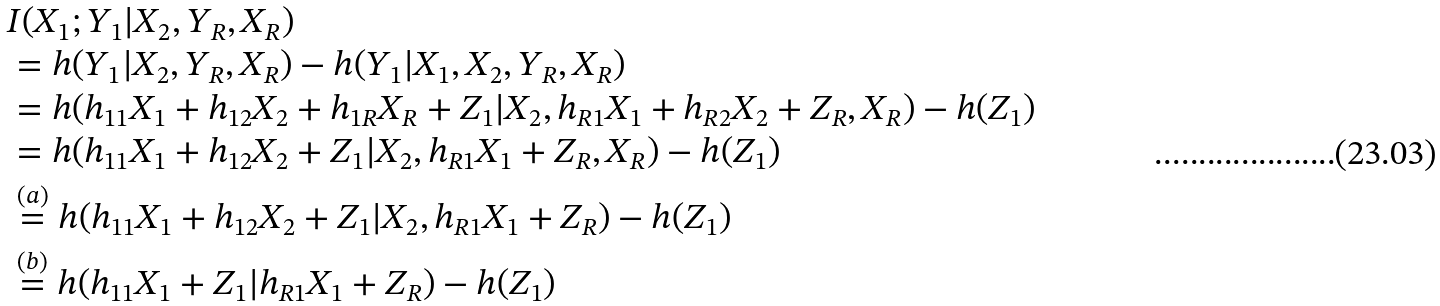<formula> <loc_0><loc_0><loc_500><loc_500>& I ( X _ { 1 } ; Y _ { 1 } | X _ { 2 } , Y _ { R } , X _ { R } ) \\ & = h ( Y _ { 1 } | X _ { 2 } , Y _ { R } , X _ { R } ) - h ( Y _ { 1 } | X _ { 1 } , X _ { 2 } , Y _ { R } , X _ { R } ) \\ & = h ( h _ { 1 1 } X _ { 1 } + h _ { 1 2 } X _ { 2 } + h _ { 1 R } X _ { R } + Z _ { 1 } | X _ { 2 } , h _ { R 1 } X _ { 1 } + h _ { R 2 } X _ { 2 } + Z _ { R } , X _ { R } ) - h ( Z _ { 1 } ) \\ & = h ( h _ { 1 1 } X _ { 1 } + h _ { 1 2 } X _ { 2 } + Z _ { 1 } | X _ { 2 } , h _ { R 1 } X _ { 1 } + Z _ { R } , X _ { R } ) - h ( Z _ { 1 } ) \\ & \overset { ( a ) } = h ( h _ { 1 1 } X _ { 1 } + h _ { 1 2 } X _ { 2 } + Z _ { 1 } | X _ { 2 } , h _ { R 1 } X _ { 1 } + Z _ { R } ) - h ( Z _ { 1 } ) \\ & \overset { ( b ) } = h ( h _ { 1 1 } X _ { 1 } + Z _ { 1 } | h _ { R 1 } X _ { 1 } + Z _ { R } ) - h ( Z _ { 1 } )</formula> 